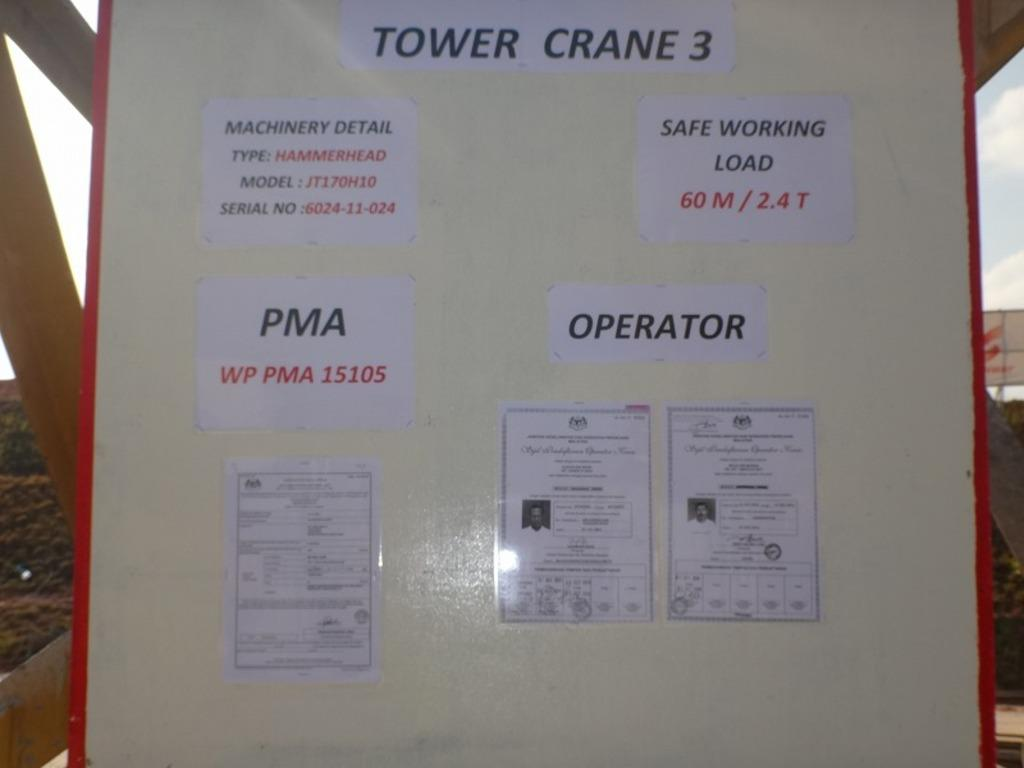<image>
Present a compact description of the photo's key features. The sign here explains the safe working load for Tower Crane 3. 